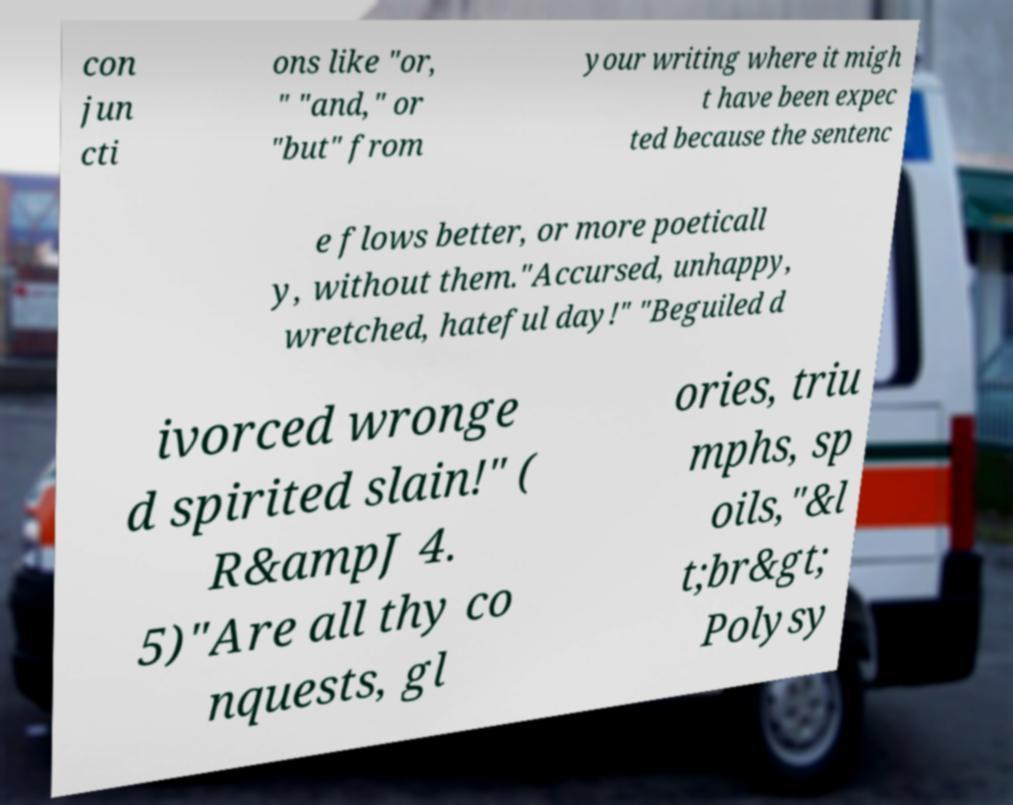Can you read and provide the text displayed in the image?This photo seems to have some interesting text. Can you extract and type it out for me? con jun cti ons like "or, " "and," or "but" from your writing where it migh t have been expec ted because the sentenc e flows better, or more poeticall y, without them."Accursed, unhappy, wretched, hateful day!" "Beguiled d ivorced wronge d spirited slain!" ( R&ampJ 4. 5)"Are all thy co nquests, gl ories, triu mphs, sp oils,"&l t;br&gt; Polysy 